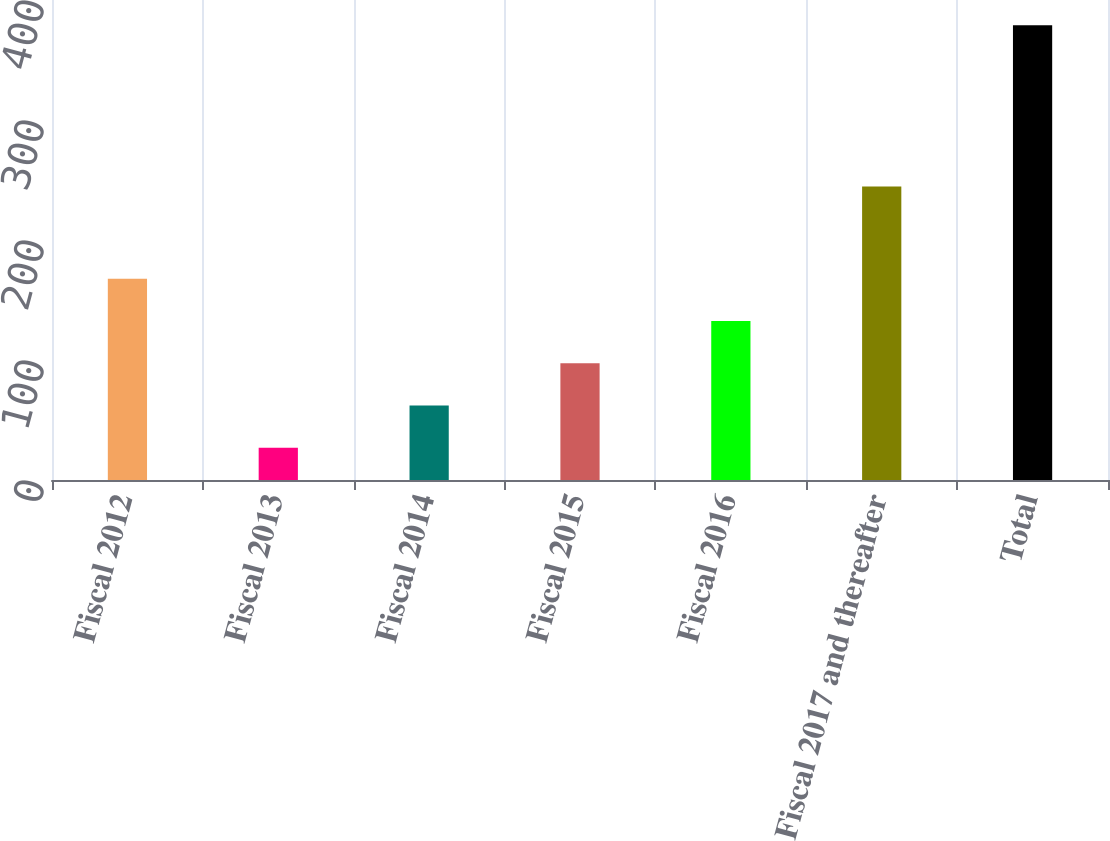Convert chart to OTSL. <chart><loc_0><loc_0><loc_500><loc_500><bar_chart><fcel>Fiscal 2012<fcel>Fiscal 2013<fcel>Fiscal 2014<fcel>Fiscal 2015<fcel>Fiscal 2016<fcel>Fiscal 2017 and thereafter<fcel>Total<nl><fcel>167.64<fcel>26.8<fcel>62.01<fcel>97.22<fcel>132.43<fcel>244.5<fcel>378.9<nl></chart> 